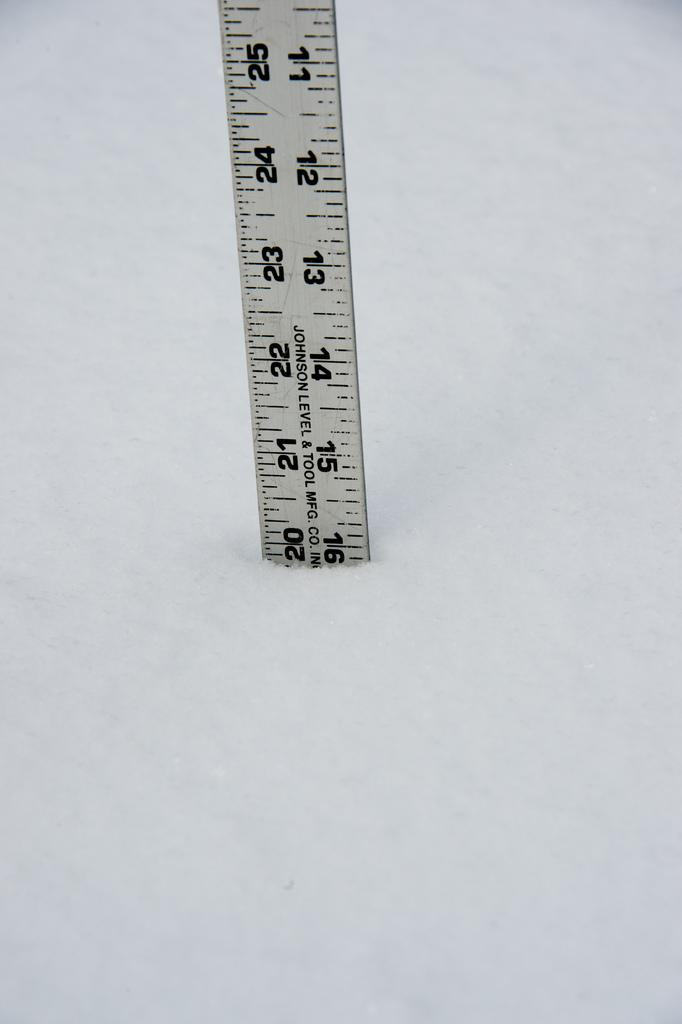What object is present in the image that is used for measuring weight? There is a scale in the image. What is the condition of the area around the scale? There is ice around the scale. What type of pin can be seen on the floor near the scale in the image? There is no pin present on the floor near the scale in the image. How many chickens are visible in the image? There are no chickens present in the image. 